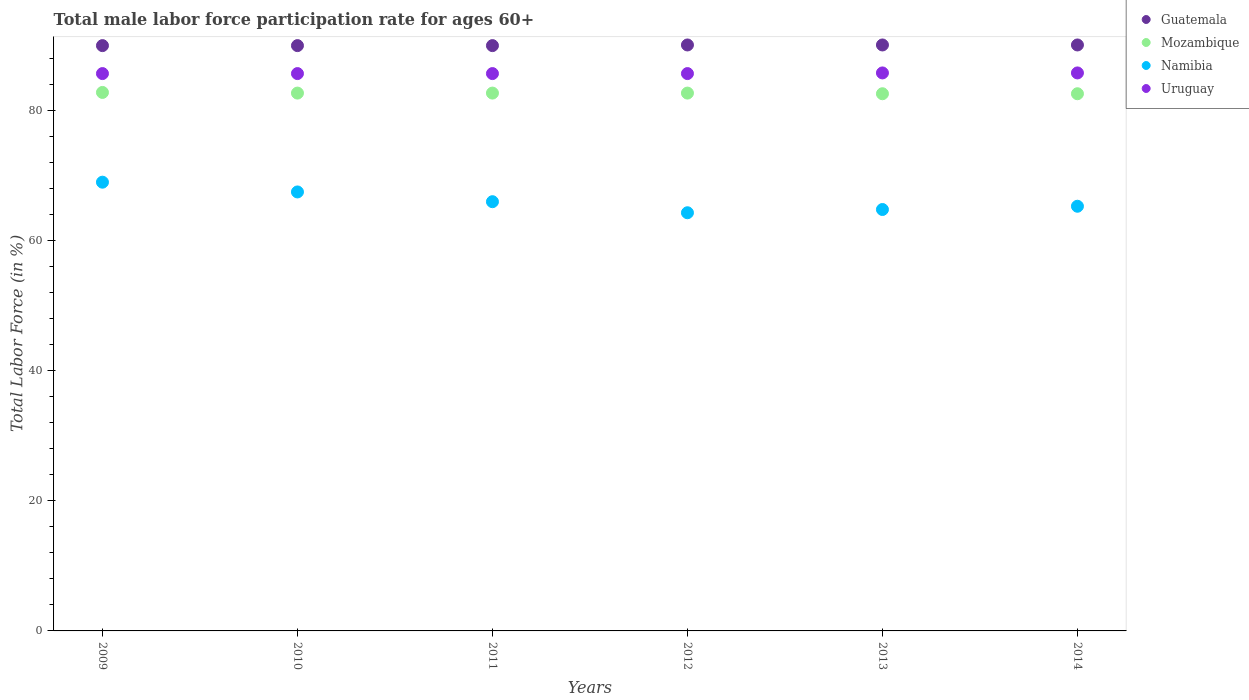How many different coloured dotlines are there?
Offer a very short reply. 4. Is the number of dotlines equal to the number of legend labels?
Ensure brevity in your answer.  Yes. What is the male labor force participation rate in Namibia in 2010?
Your answer should be compact. 67.5. Across all years, what is the maximum male labor force participation rate in Mozambique?
Your response must be concise. 82.8. Across all years, what is the minimum male labor force participation rate in Namibia?
Offer a very short reply. 64.3. What is the total male labor force participation rate in Mozambique in the graph?
Provide a succinct answer. 496.1. What is the difference between the male labor force participation rate in Uruguay in 2011 and that in 2014?
Provide a short and direct response. -0.1. What is the difference between the male labor force participation rate in Mozambique in 2009 and the male labor force participation rate in Guatemala in 2012?
Your response must be concise. -7.3. What is the average male labor force participation rate in Mozambique per year?
Offer a very short reply. 82.68. In the year 2009, what is the difference between the male labor force participation rate in Mozambique and male labor force participation rate in Guatemala?
Give a very brief answer. -7.2. In how many years, is the male labor force participation rate in Uruguay greater than 16 %?
Offer a very short reply. 6. What is the ratio of the male labor force participation rate in Namibia in 2010 to that in 2013?
Ensure brevity in your answer.  1.04. What is the difference between the highest and the lowest male labor force participation rate in Uruguay?
Your response must be concise. 0.1. Is the sum of the male labor force participation rate in Mozambique in 2009 and 2014 greater than the maximum male labor force participation rate in Namibia across all years?
Make the answer very short. Yes. Is the male labor force participation rate in Guatemala strictly greater than the male labor force participation rate in Namibia over the years?
Your answer should be very brief. Yes. Does the graph contain grids?
Offer a very short reply. No. How are the legend labels stacked?
Provide a succinct answer. Vertical. What is the title of the graph?
Provide a short and direct response. Total male labor force participation rate for ages 60+. Does "St. Lucia" appear as one of the legend labels in the graph?
Give a very brief answer. No. What is the label or title of the X-axis?
Your response must be concise. Years. What is the Total Labor Force (in %) of Guatemala in 2009?
Offer a very short reply. 90. What is the Total Labor Force (in %) of Mozambique in 2009?
Provide a succinct answer. 82.8. What is the Total Labor Force (in %) of Namibia in 2009?
Make the answer very short. 69. What is the Total Labor Force (in %) in Uruguay in 2009?
Provide a succinct answer. 85.7. What is the Total Labor Force (in %) in Mozambique in 2010?
Your answer should be very brief. 82.7. What is the Total Labor Force (in %) in Namibia in 2010?
Provide a short and direct response. 67.5. What is the Total Labor Force (in %) in Uruguay in 2010?
Provide a succinct answer. 85.7. What is the Total Labor Force (in %) of Guatemala in 2011?
Your response must be concise. 90. What is the Total Labor Force (in %) of Mozambique in 2011?
Offer a very short reply. 82.7. What is the Total Labor Force (in %) in Uruguay in 2011?
Give a very brief answer. 85.7. What is the Total Labor Force (in %) in Guatemala in 2012?
Keep it short and to the point. 90.1. What is the Total Labor Force (in %) of Mozambique in 2012?
Keep it short and to the point. 82.7. What is the Total Labor Force (in %) in Namibia in 2012?
Give a very brief answer. 64.3. What is the Total Labor Force (in %) in Uruguay in 2012?
Provide a succinct answer. 85.7. What is the Total Labor Force (in %) of Guatemala in 2013?
Ensure brevity in your answer.  90.1. What is the Total Labor Force (in %) of Mozambique in 2013?
Your answer should be compact. 82.6. What is the Total Labor Force (in %) in Namibia in 2013?
Provide a succinct answer. 64.8. What is the Total Labor Force (in %) in Uruguay in 2013?
Your answer should be compact. 85.8. What is the Total Labor Force (in %) of Guatemala in 2014?
Give a very brief answer. 90.1. What is the Total Labor Force (in %) of Mozambique in 2014?
Your answer should be very brief. 82.6. What is the Total Labor Force (in %) in Namibia in 2014?
Make the answer very short. 65.3. What is the Total Labor Force (in %) in Uruguay in 2014?
Make the answer very short. 85.8. Across all years, what is the maximum Total Labor Force (in %) of Guatemala?
Offer a very short reply. 90.1. Across all years, what is the maximum Total Labor Force (in %) in Mozambique?
Provide a short and direct response. 82.8. Across all years, what is the maximum Total Labor Force (in %) of Namibia?
Make the answer very short. 69. Across all years, what is the maximum Total Labor Force (in %) of Uruguay?
Your response must be concise. 85.8. Across all years, what is the minimum Total Labor Force (in %) in Guatemala?
Your answer should be very brief. 90. Across all years, what is the minimum Total Labor Force (in %) in Mozambique?
Provide a succinct answer. 82.6. Across all years, what is the minimum Total Labor Force (in %) in Namibia?
Your answer should be compact. 64.3. Across all years, what is the minimum Total Labor Force (in %) in Uruguay?
Ensure brevity in your answer.  85.7. What is the total Total Labor Force (in %) in Guatemala in the graph?
Your answer should be compact. 540.3. What is the total Total Labor Force (in %) of Mozambique in the graph?
Your answer should be very brief. 496.1. What is the total Total Labor Force (in %) of Namibia in the graph?
Offer a very short reply. 396.9. What is the total Total Labor Force (in %) of Uruguay in the graph?
Give a very brief answer. 514.4. What is the difference between the Total Labor Force (in %) in Guatemala in 2009 and that in 2010?
Offer a very short reply. 0. What is the difference between the Total Labor Force (in %) of Namibia in 2009 and that in 2010?
Provide a succinct answer. 1.5. What is the difference between the Total Labor Force (in %) in Uruguay in 2009 and that in 2010?
Give a very brief answer. 0. What is the difference between the Total Labor Force (in %) of Guatemala in 2009 and that in 2011?
Keep it short and to the point. 0. What is the difference between the Total Labor Force (in %) of Mozambique in 2009 and that in 2011?
Provide a short and direct response. 0.1. What is the difference between the Total Labor Force (in %) in Uruguay in 2009 and that in 2011?
Ensure brevity in your answer.  0. What is the difference between the Total Labor Force (in %) of Mozambique in 2009 and that in 2012?
Make the answer very short. 0.1. What is the difference between the Total Labor Force (in %) of Namibia in 2009 and that in 2012?
Make the answer very short. 4.7. What is the difference between the Total Labor Force (in %) in Uruguay in 2009 and that in 2012?
Your answer should be compact. 0. What is the difference between the Total Labor Force (in %) in Mozambique in 2009 and that in 2013?
Offer a terse response. 0.2. What is the difference between the Total Labor Force (in %) in Namibia in 2009 and that in 2013?
Make the answer very short. 4.2. What is the difference between the Total Labor Force (in %) of Uruguay in 2009 and that in 2013?
Offer a terse response. -0.1. What is the difference between the Total Labor Force (in %) in Guatemala in 2009 and that in 2014?
Give a very brief answer. -0.1. What is the difference between the Total Labor Force (in %) of Mozambique in 2009 and that in 2014?
Provide a short and direct response. 0.2. What is the difference between the Total Labor Force (in %) in Namibia in 2009 and that in 2014?
Your answer should be very brief. 3.7. What is the difference between the Total Labor Force (in %) in Guatemala in 2010 and that in 2011?
Give a very brief answer. 0. What is the difference between the Total Labor Force (in %) of Uruguay in 2010 and that in 2011?
Your response must be concise. 0. What is the difference between the Total Labor Force (in %) in Guatemala in 2010 and that in 2012?
Your answer should be compact. -0.1. What is the difference between the Total Labor Force (in %) in Mozambique in 2010 and that in 2012?
Your response must be concise. 0. What is the difference between the Total Labor Force (in %) of Namibia in 2010 and that in 2012?
Give a very brief answer. 3.2. What is the difference between the Total Labor Force (in %) in Uruguay in 2010 and that in 2012?
Ensure brevity in your answer.  0. What is the difference between the Total Labor Force (in %) of Mozambique in 2010 and that in 2013?
Your answer should be very brief. 0.1. What is the difference between the Total Labor Force (in %) of Uruguay in 2010 and that in 2013?
Your answer should be compact. -0.1. What is the difference between the Total Labor Force (in %) in Guatemala in 2010 and that in 2014?
Keep it short and to the point. -0.1. What is the difference between the Total Labor Force (in %) of Mozambique in 2010 and that in 2014?
Give a very brief answer. 0.1. What is the difference between the Total Labor Force (in %) in Namibia in 2010 and that in 2014?
Provide a succinct answer. 2.2. What is the difference between the Total Labor Force (in %) of Guatemala in 2011 and that in 2012?
Keep it short and to the point. -0.1. What is the difference between the Total Labor Force (in %) of Mozambique in 2011 and that in 2012?
Provide a succinct answer. 0. What is the difference between the Total Labor Force (in %) in Uruguay in 2011 and that in 2012?
Keep it short and to the point. 0. What is the difference between the Total Labor Force (in %) in Mozambique in 2011 and that in 2013?
Provide a short and direct response. 0.1. What is the difference between the Total Labor Force (in %) of Namibia in 2011 and that in 2013?
Your answer should be compact. 1.2. What is the difference between the Total Labor Force (in %) in Uruguay in 2011 and that in 2014?
Give a very brief answer. -0.1. What is the difference between the Total Labor Force (in %) in Guatemala in 2012 and that in 2013?
Your answer should be compact. 0. What is the difference between the Total Labor Force (in %) in Mozambique in 2012 and that in 2013?
Provide a succinct answer. 0.1. What is the difference between the Total Labor Force (in %) of Guatemala in 2012 and that in 2014?
Offer a very short reply. 0. What is the difference between the Total Labor Force (in %) of Namibia in 2012 and that in 2014?
Offer a very short reply. -1. What is the difference between the Total Labor Force (in %) of Guatemala in 2013 and that in 2014?
Keep it short and to the point. 0. What is the difference between the Total Labor Force (in %) in Guatemala in 2009 and the Total Labor Force (in %) in Mozambique in 2010?
Your answer should be compact. 7.3. What is the difference between the Total Labor Force (in %) in Guatemala in 2009 and the Total Labor Force (in %) in Namibia in 2010?
Offer a very short reply. 22.5. What is the difference between the Total Labor Force (in %) of Namibia in 2009 and the Total Labor Force (in %) of Uruguay in 2010?
Offer a terse response. -16.7. What is the difference between the Total Labor Force (in %) of Guatemala in 2009 and the Total Labor Force (in %) of Uruguay in 2011?
Keep it short and to the point. 4.3. What is the difference between the Total Labor Force (in %) of Mozambique in 2009 and the Total Labor Force (in %) of Uruguay in 2011?
Keep it short and to the point. -2.9. What is the difference between the Total Labor Force (in %) in Namibia in 2009 and the Total Labor Force (in %) in Uruguay in 2011?
Provide a short and direct response. -16.7. What is the difference between the Total Labor Force (in %) in Guatemala in 2009 and the Total Labor Force (in %) in Namibia in 2012?
Ensure brevity in your answer.  25.7. What is the difference between the Total Labor Force (in %) in Guatemala in 2009 and the Total Labor Force (in %) in Uruguay in 2012?
Your answer should be compact. 4.3. What is the difference between the Total Labor Force (in %) of Mozambique in 2009 and the Total Labor Force (in %) of Namibia in 2012?
Provide a succinct answer. 18.5. What is the difference between the Total Labor Force (in %) in Namibia in 2009 and the Total Labor Force (in %) in Uruguay in 2012?
Offer a very short reply. -16.7. What is the difference between the Total Labor Force (in %) of Guatemala in 2009 and the Total Labor Force (in %) of Mozambique in 2013?
Ensure brevity in your answer.  7.4. What is the difference between the Total Labor Force (in %) of Guatemala in 2009 and the Total Labor Force (in %) of Namibia in 2013?
Provide a succinct answer. 25.2. What is the difference between the Total Labor Force (in %) of Mozambique in 2009 and the Total Labor Force (in %) of Uruguay in 2013?
Keep it short and to the point. -3. What is the difference between the Total Labor Force (in %) in Namibia in 2009 and the Total Labor Force (in %) in Uruguay in 2013?
Offer a very short reply. -16.8. What is the difference between the Total Labor Force (in %) of Guatemala in 2009 and the Total Labor Force (in %) of Namibia in 2014?
Keep it short and to the point. 24.7. What is the difference between the Total Labor Force (in %) of Mozambique in 2009 and the Total Labor Force (in %) of Namibia in 2014?
Keep it short and to the point. 17.5. What is the difference between the Total Labor Force (in %) of Namibia in 2009 and the Total Labor Force (in %) of Uruguay in 2014?
Ensure brevity in your answer.  -16.8. What is the difference between the Total Labor Force (in %) in Guatemala in 2010 and the Total Labor Force (in %) in Mozambique in 2011?
Your response must be concise. 7.3. What is the difference between the Total Labor Force (in %) in Guatemala in 2010 and the Total Labor Force (in %) in Namibia in 2011?
Make the answer very short. 24. What is the difference between the Total Labor Force (in %) in Namibia in 2010 and the Total Labor Force (in %) in Uruguay in 2011?
Make the answer very short. -18.2. What is the difference between the Total Labor Force (in %) in Guatemala in 2010 and the Total Labor Force (in %) in Namibia in 2012?
Your answer should be compact. 25.7. What is the difference between the Total Labor Force (in %) in Guatemala in 2010 and the Total Labor Force (in %) in Uruguay in 2012?
Your answer should be compact. 4.3. What is the difference between the Total Labor Force (in %) in Mozambique in 2010 and the Total Labor Force (in %) in Namibia in 2012?
Make the answer very short. 18.4. What is the difference between the Total Labor Force (in %) of Namibia in 2010 and the Total Labor Force (in %) of Uruguay in 2012?
Your answer should be very brief. -18.2. What is the difference between the Total Labor Force (in %) in Guatemala in 2010 and the Total Labor Force (in %) in Mozambique in 2013?
Provide a short and direct response. 7.4. What is the difference between the Total Labor Force (in %) of Guatemala in 2010 and the Total Labor Force (in %) of Namibia in 2013?
Your answer should be very brief. 25.2. What is the difference between the Total Labor Force (in %) of Mozambique in 2010 and the Total Labor Force (in %) of Uruguay in 2013?
Offer a terse response. -3.1. What is the difference between the Total Labor Force (in %) in Namibia in 2010 and the Total Labor Force (in %) in Uruguay in 2013?
Keep it short and to the point. -18.3. What is the difference between the Total Labor Force (in %) of Guatemala in 2010 and the Total Labor Force (in %) of Namibia in 2014?
Provide a short and direct response. 24.7. What is the difference between the Total Labor Force (in %) of Guatemala in 2010 and the Total Labor Force (in %) of Uruguay in 2014?
Provide a short and direct response. 4.2. What is the difference between the Total Labor Force (in %) of Mozambique in 2010 and the Total Labor Force (in %) of Namibia in 2014?
Give a very brief answer. 17.4. What is the difference between the Total Labor Force (in %) in Namibia in 2010 and the Total Labor Force (in %) in Uruguay in 2014?
Provide a succinct answer. -18.3. What is the difference between the Total Labor Force (in %) of Guatemala in 2011 and the Total Labor Force (in %) of Mozambique in 2012?
Offer a terse response. 7.3. What is the difference between the Total Labor Force (in %) of Guatemala in 2011 and the Total Labor Force (in %) of Namibia in 2012?
Ensure brevity in your answer.  25.7. What is the difference between the Total Labor Force (in %) in Guatemala in 2011 and the Total Labor Force (in %) in Uruguay in 2012?
Your answer should be very brief. 4.3. What is the difference between the Total Labor Force (in %) in Mozambique in 2011 and the Total Labor Force (in %) in Namibia in 2012?
Your answer should be compact. 18.4. What is the difference between the Total Labor Force (in %) in Namibia in 2011 and the Total Labor Force (in %) in Uruguay in 2012?
Keep it short and to the point. -19.7. What is the difference between the Total Labor Force (in %) in Guatemala in 2011 and the Total Labor Force (in %) in Namibia in 2013?
Your answer should be very brief. 25.2. What is the difference between the Total Labor Force (in %) in Mozambique in 2011 and the Total Labor Force (in %) in Namibia in 2013?
Keep it short and to the point. 17.9. What is the difference between the Total Labor Force (in %) in Mozambique in 2011 and the Total Labor Force (in %) in Uruguay in 2013?
Keep it short and to the point. -3.1. What is the difference between the Total Labor Force (in %) in Namibia in 2011 and the Total Labor Force (in %) in Uruguay in 2013?
Your response must be concise. -19.8. What is the difference between the Total Labor Force (in %) of Guatemala in 2011 and the Total Labor Force (in %) of Mozambique in 2014?
Give a very brief answer. 7.4. What is the difference between the Total Labor Force (in %) in Guatemala in 2011 and the Total Labor Force (in %) in Namibia in 2014?
Offer a terse response. 24.7. What is the difference between the Total Labor Force (in %) in Namibia in 2011 and the Total Labor Force (in %) in Uruguay in 2014?
Your answer should be compact. -19.8. What is the difference between the Total Labor Force (in %) of Guatemala in 2012 and the Total Labor Force (in %) of Mozambique in 2013?
Your answer should be very brief. 7.5. What is the difference between the Total Labor Force (in %) of Guatemala in 2012 and the Total Labor Force (in %) of Namibia in 2013?
Make the answer very short. 25.3. What is the difference between the Total Labor Force (in %) in Mozambique in 2012 and the Total Labor Force (in %) in Namibia in 2013?
Your answer should be very brief. 17.9. What is the difference between the Total Labor Force (in %) of Mozambique in 2012 and the Total Labor Force (in %) of Uruguay in 2013?
Provide a succinct answer. -3.1. What is the difference between the Total Labor Force (in %) in Namibia in 2012 and the Total Labor Force (in %) in Uruguay in 2013?
Offer a very short reply. -21.5. What is the difference between the Total Labor Force (in %) of Guatemala in 2012 and the Total Labor Force (in %) of Namibia in 2014?
Your response must be concise. 24.8. What is the difference between the Total Labor Force (in %) in Guatemala in 2012 and the Total Labor Force (in %) in Uruguay in 2014?
Keep it short and to the point. 4.3. What is the difference between the Total Labor Force (in %) in Mozambique in 2012 and the Total Labor Force (in %) in Uruguay in 2014?
Provide a succinct answer. -3.1. What is the difference between the Total Labor Force (in %) in Namibia in 2012 and the Total Labor Force (in %) in Uruguay in 2014?
Make the answer very short. -21.5. What is the difference between the Total Labor Force (in %) of Guatemala in 2013 and the Total Labor Force (in %) of Namibia in 2014?
Offer a very short reply. 24.8. What is the difference between the Total Labor Force (in %) of Guatemala in 2013 and the Total Labor Force (in %) of Uruguay in 2014?
Offer a very short reply. 4.3. What is the difference between the Total Labor Force (in %) in Mozambique in 2013 and the Total Labor Force (in %) in Namibia in 2014?
Provide a short and direct response. 17.3. What is the difference between the Total Labor Force (in %) of Mozambique in 2013 and the Total Labor Force (in %) of Uruguay in 2014?
Your response must be concise. -3.2. What is the difference between the Total Labor Force (in %) of Namibia in 2013 and the Total Labor Force (in %) of Uruguay in 2014?
Make the answer very short. -21. What is the average Total Labor Force (in %) of Guatemala per year?
Keep it short and to the point. 90.05. What is the average Total Labor Force (in %) of Mozambique per year?
Ensure brevity in your answer.  82.68. What is the average Total Labor Force (in %) of Namibia per year?
Your answer should be compact. 66.15. What is the average Total Labor Force (in %) in Uruguay per year?
Your response must be concise. 85.73. In the year 2009, what is the difference between the Total Labor Force (in %) of Guatemala and Total Labor Force (in %) of Mozambique?
Your answer should be compact. 7.2. In the year 2009, what is the difference between the Total Labor Force (in %) in Guatemala and Total Labor Force (in %) in Namibia?
Ensure brevity in your answer.  21. In the year 2009, what is the difference between the Total Labor Force (in %) in Guatemala and Total Labor Force (in %) in Uruguay?
Offer a terse response. 4.3. In the year 2009, what is the difference between the Total Labor Force (in %) in Mozambique and Total Labor Force (in %) in Namibia?
Make the answer very short. 13.8. In the year 2009, what is the difference between the Total Labor Force (in %) in Namibia and Total Labor Force (in %) in Uruguay?
Offer a very short reply. -16.7. In the year 2010, what is the difference between the Total Labor Force (in %) in Guatemala and Total Labor Force (in %) in Mozambique?
Offer a very short reply. 7.3. In the year 2010, what is the difference between the Total Labor Force (in %) of Mozambique and Total Labor Force (in %) of Namibia?
Ensure brevity in your answer.  15.2. In the year 2010, what is the difference between the Total Labor Force (in %) in Mozambique and Total Labor Force (in %) in Uruguay?
Give a very brief answer. -3. In the year 2010, what is the difference between the Total Labor Force (in %) of Namibia and Total Labor Force (in %) of Uruguay?
Provide a succinct answer. -18.2. In the year 2011, what is the difference between the Total Labor Force (in %) in Guatemala and Total Labor Force (in %) in Uruguay?
Provide a short and direct response. 4.3. In the year 2011, what is the difference between the Total Labor Force (in %) of Mozambique and Total Labor Force (in %) of Uruguay?
Ensure brevity in your answer.  -3. In the year 2011, what is the difference between the Total Labor Force (in %) of Namibia and Total Labor Force (in %) of Uruguay?
Make the answer very short. -19.7. In the year 2012, what is the difference between the Total Labor Force (in %) in Guatemala and Total Labor Force (in %) in Namibia?
Provide a short and direct response. 25.8. In the year 2012, what is the difference between the Total Labor Force (in %) of Guatemala and Total Labor Force (in %) of Uruguay?
Your answer should be very brief. 4.4. In the year 2012, what is the difference between the Total Labor Force (in %) of Mozambique and Total Labor Force (in %) of Uruguay?
Offer a terse response. -3. In the year 2012, what is the difference between the Total Labor Force (in %) of Namibia and Total Labor Force (in %) of Uruguay?
Offer a very short reply. -21.4. In the year 2013, what is the difference between the Total Labor Force (in %) in Guatemala and Total Labor Force (in %) in Namibia?
Keep it short and to the point. 25.3. In the year 2013, what is the difference between the Total Labor Force (in %) in Mozambique and Total Labor Force (in %) in Uruguay?
Your response must be concise. -3.2. In the year 2013, what is the difference between the Total Labor Force (in %) of Namibia and Total Labor Force (in %) of Uruguay?
Offer a terse response. -21. In the year 2014, what is the difference between the Total Labor Force (in %) of Guatemala and Total Labor Force (in %) of Namibia?
Your answer should be compact. 24.8. In the year 2014, what is the difference between the Total Labor Force (in %) in Mozambique and Total Labor Force (in %) in Namibia?
Ensure brevity in your answer.  17.3. In the year 2014, what is the difference between the Total Labor Force (in %) in Mozambique and Total Labor Force (in %) in Uruguay?
Give a very brief answer. -3.2. In the year 2014, what is the difference between the Total Labor Force (in %) of Namibia and Total Labor Force (in %) of Uruguay?
Offer a terse response. -20.5. What is the ratio of the Total Labor Force (in %) of Guatemala in 2009 to that in 2010?
Ensure brevity in your answer.  1. What is the ratio of the Total Labor Force (in %) of Namibia in 2009 to that in 2010?
Your response must be concise. 1.02. What is the ratio of the Total Labor Force (in %) of Guatemala in 2009 to that in 2011?
Keep it short and to the point. 1. What is the ratio of the Total Labor Force (in %) of Namibia in 2009 to that in 2011?
Your response must be concise. 1.05. What is the ratio of the Total Labor Force (in %) of Uruguay in 2009 to that in 2011?
Keep it short and to the point. 1. What is the ratio of the Total Labor Force (in %) of Guatemala in 2009 to that in 2012?
Offer a very short reply. 1. What is the ratio of the Total Labor Force (in %) of Namibia in 2009 to that in 2012?
Offer a terse response. 1.07. What is the ratio of the Total Labor Force (in %) in Uruguay in 2009 to that in 2012?
Offer a terse response. 1. What is the ratio of the Total Labor Force (in %) of Guatemala in 2009 to that in 2013?
Provide a succinct answer. 1. What is the ratio of the Total Labor Force (in %) in Namibia in 2009 to that in 2013?
Give a very brief answer. 1.06. What is the ratio of the Total Labor Force (in %) in Uruguay in 2009 to that in 2013?
Give a very brief answer. 1. What is the ratio of the Total Labor Force (in %) of Guatemala in 2009 to that in 2014?
Your answer should be very brief. 1. What is the ratio of the Total Labor Force (in %) in Mozambique in 2009 to that in 2014?
Ensure brevity in your answer.  1. What is the ratio of the Total Labor Force (in %) of Namibia in 2009 to that in 2014?
Your answer should be very brief. 1.06. What is the ratio of the Total Labor Force (in %) of Uruguay in 2009 to that in 2014?
Keep it short and to the point. 1. What is the ratio of the Total Labor Force (in %) in Guatemala in 2010 to that in 2011?
Ensure brevity in your answer.  1. What is the ratio of the Total Labor Force (in %) in Namibia in 2010 to that in 2011?
Ensure brevity in your answer.  1.02. What is the ratio of the Total Labor Force (in %) in Uruguay in 2010 to that in 2011?
Ensure brevity in your answer.  1. What is the ratio of the Total Labor Force (in %) in Mozambique in 2010 to that in 2012?
Provide a succinct answer. 1. What is the ratio of the Total Labor Force (in %) of Namibia in 2010 to that in 2012?
Ensure brevity in your answer.  1.05. What is the ratio of the Total Labor Force (in %) of Uruguay in 2010 to that in 2012?
Give a very brief answer. 1. What is the ratio of the Total Labor Force (in %) of Namibia in 2010 to that in 2013?
Your answer should be compact. 1.04. What is the ratio of the Total Labor Force (in %) in Uruguay in 2010 to that in 2013?
Your response must be concise. 1. What is the ratio of the Total Labor Force (in %) of Namibia in 2010 to that in 2014?
Give a very brief answer. 1.03. What is the ratio of the Total Labor Force (in %) in Mozambique in 2011 to that in 2012?
Keep it short and to the point. 1. What is the ratio of the Total Labor Force (in %) in Namibia in 2011 to that in 2012?
Offer a very short reply. 1.03. What is the ratio of the Total Labor Force (in %) in Guatemala in 2011 to that in 2013?
Your response must be concise. 1. What is the ratio of the Total Labor Force (in %) in Namibia in 2011 to that in 2013?
Your answer should be very brief. 1.02. What is the ratio of the Total Labor Force (in %) of Mozambique in 2011 to that in 2014?
Offer a terse response. 1. What is the ratio of the Total Labor Force (in %) in Namibia in 2011 to that in 2014?
Your answer should be compact. 1.01. What is the ratio of the Total Labor Force (in %) in Uruguay in 2011 to that in 2014?
Offer a terse response. 1. What is the ratio of the Total Labor Force (in %) of Mozambique in 2012 to that in 2013?
Ensure brevity in your answer.  1. What is the ratio of the Total Labor Force (in %) in Namibia in 2012 to that in 2013?
Make the answer very short. 0.99. What is the ratio of the Total Labor Force (in %) in Uruguay in 2012 to that in 2013?
Your answer should be compact. 1. What is the ratio of the Total Labor Force (in %) of Guatemala in 2012 to that in 2014?
Give a very brief answer. 1. What is the ratio of the Total Labor Force (in %) of Namibia in 2012 to that in 2014?
Offer a very short reply. 0.98. What is the ratio of the Total Labor Force (in %) in Uruguay in 2012 to that in 2014?
Your response must be concise. 1. What is the ratio of the Total Labor Force (in %) of Namibia in 2013 to that in 2014?
Offer a terse response. 0.99. What is the difference between the highest and the second highest Total Labor Force (in %) in Guatemala?
Your answer should be very brief. 0. What is the difference between the highest and the second highest Total Labor Force (in %) in Mozambique?
Offer a very short reply. 0.1. What is the difference between the highest and the second highest Total Labor Force (in %) in Namibia?
Give a very brief answer. 1.5. What is the difference between the highest and the second highest Total Labor Force (in %) of Uruguay?
Your answer should be compact. 0. What is the difference between the highest and the lowest Total Labor Force (in %) of Guatemala?
Your response must be concise. 0.1. What is the difference between the highest and the lowest Total Labor Force (in %) in Uruguay?
Ensure brevity in your answer.  0.1. 